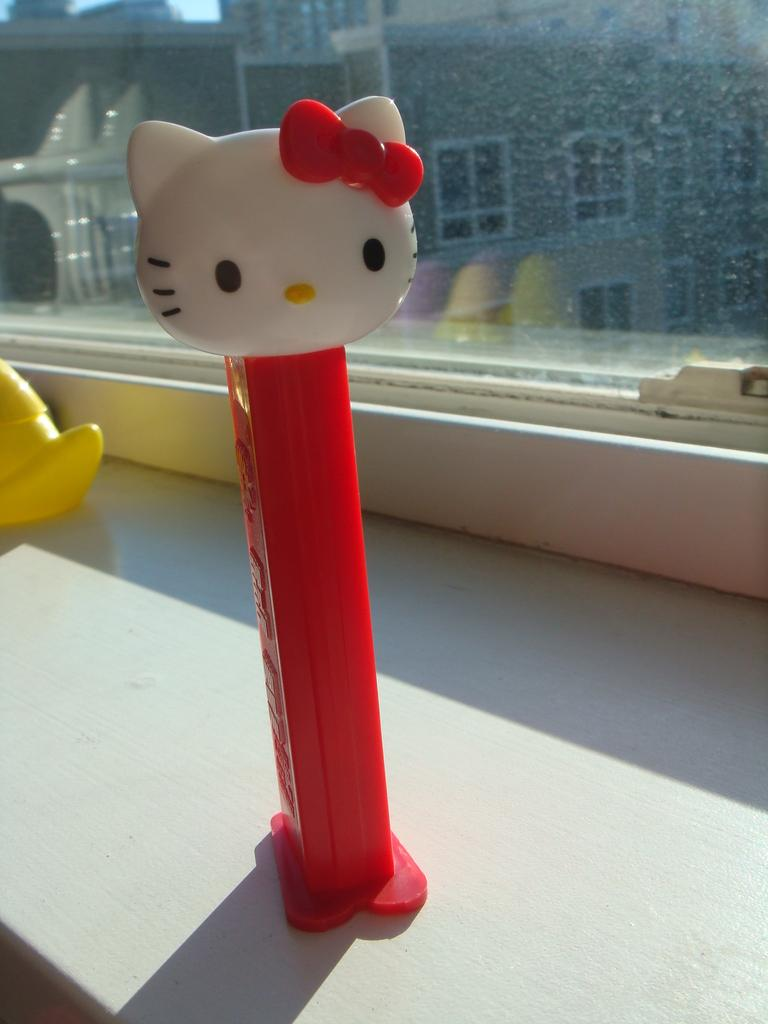What object can be seen in the image? There is a toy in the image. What colors are present on the toy? The toy is red and white in color. What can be seen in the background of the image? There is a glass window in the background of the image. What condition is the toy in after being kicked by a child in the image? There is no indication in the image that the toy has been kicked or that there is a child present. 